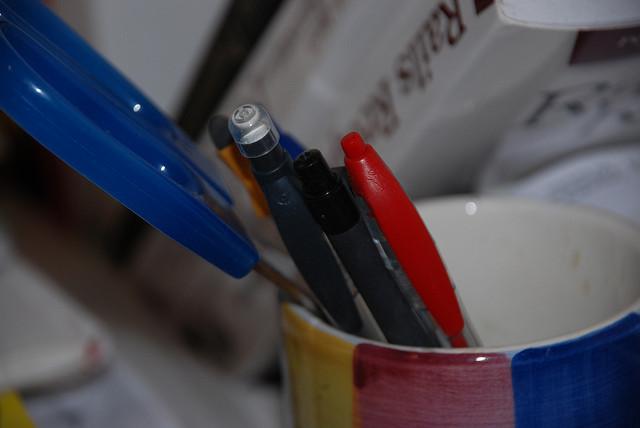Are there more pencils in the cup than pens?
Write a very short answer. No. What color is the scissor handle?
Be succinct. Blue. What color is the inside of the cup?
Concise answer only. White. 